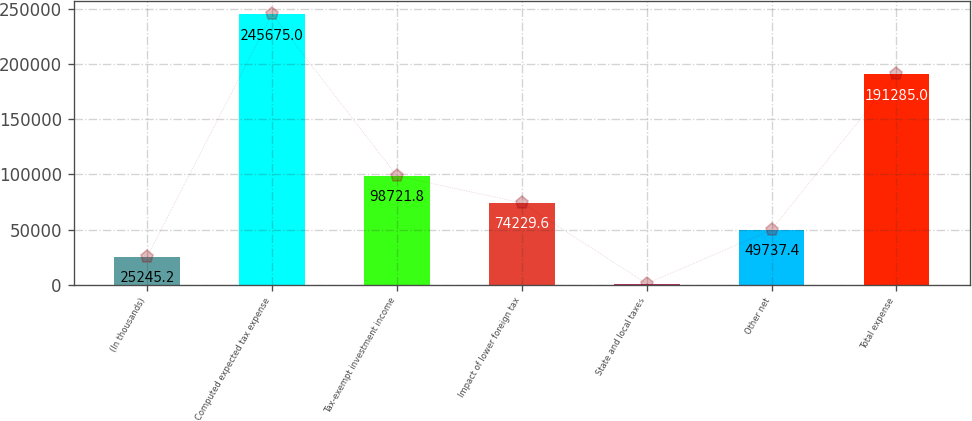<chart> <loc_0><loc_0><loc_500><loc_500><bar_chart><fcel>(In thousands)<fcel>Computed expected tax expense<fcel>Tax-exempt investment income<fcel>Impact of lower foreign tax<fcel>State and local taxes<fcel>Other net<fcel>Total expense<nl><fcel>25245.2<fcel>245675<fcel>98721.8<fcel>74229.6<fcel>753<fcel>49737.4<fcel>191285<nl></chart> 